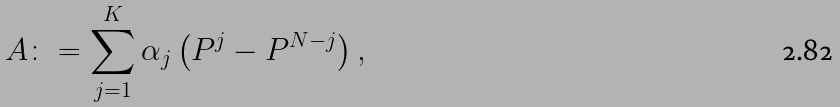<formula> <loc_0><loc_0><loc_500><loc_500>A \colon = \sum _ { j = 1 } ^ { K } \alpha _ { j } \left ( P ^ { j } - P ^ { N - j } \right ) ,</formula> 